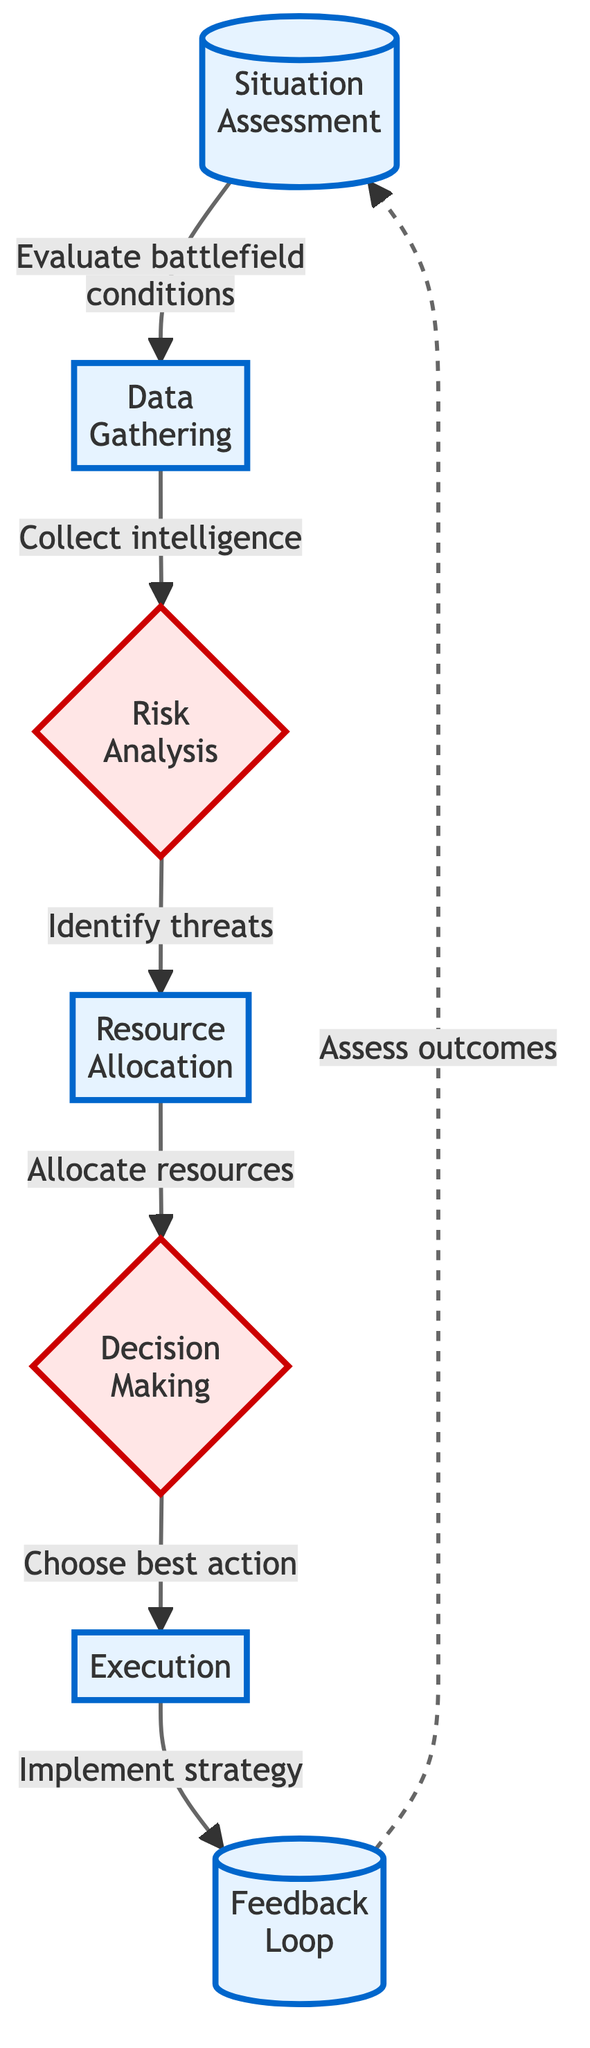What is the first step in the decision-making process? The first node in the diagram is "Situation Assessment," which represents the initial step in evaluating battlefield conditions.
Answer: Situation Assessment How many process nodes are present in the diagram? Counting the nodes labeled as process nodes, we identify four: Situation Assessment, Data Gathering, Resource Allocation, and Execution.
Answer: Four What happens after Data Gathering? Following the Data Gathering step, the next node in the flow is "Risk Analysis," indicating that after gathering data, the focus shifts to analyzing risks.
Answer: Risk Analysis What is the output of Risk Analysis? The output of Risk Analysis leads to "Resource Allocation," meaning that the evaluation of risks influences how resources are allocated for the mission.
Answer: Resource Allocation Which node obtains feedback for future decisions? The node labeled as "Feedback Loop" is specifically designated to assess outcomes and gather feedback for improving future decisions.
Answer: Feedback Loop How does Execution relate to Decision Making? The flow indicates that after Decision Making, the path leads directly to Execution, meaning that the chosen course of action is implemented following the decision.
Answer: Directly leads to Execution What is the main purpose of the Feedback Loop in this process? The feedback loop assesses the outcomes of the executed strategy and gathers insights, which are then relating back to the initial step of situation assessment.
Answer: Assess outcomes 